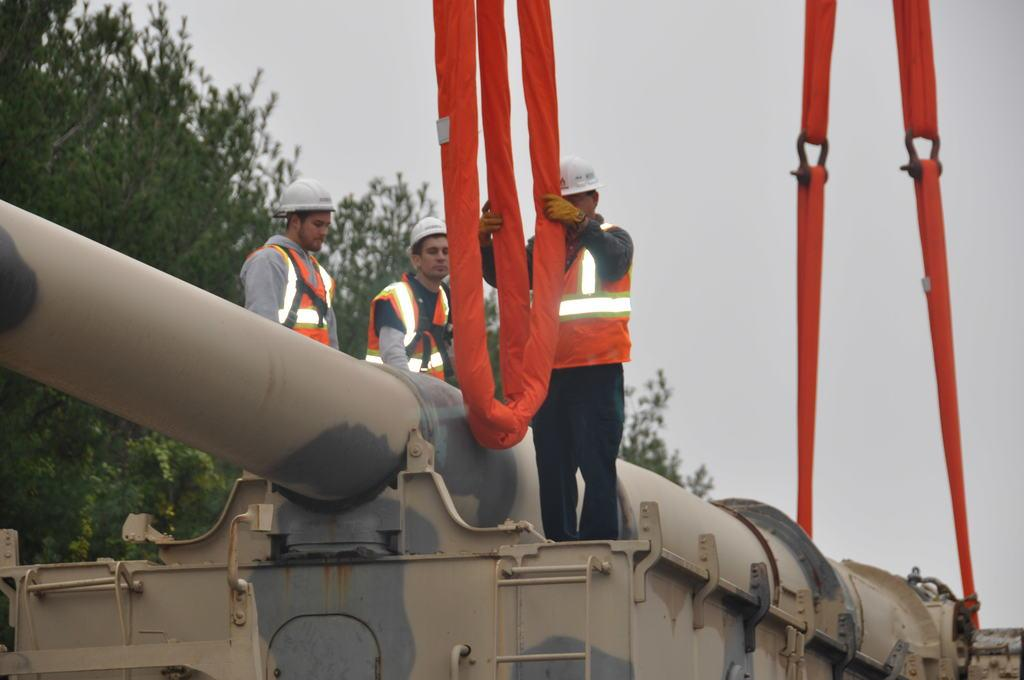How many people are present in the image? There are three people standing in the image. What type of vehicle can be seen in the image? There appears to be a military vehicle in the image. What objects are visible that could be used for tying or securing? There are ropes visible in the image. What type of natural environment is present in the image? There are trees in the image, indicating a forest or wooded area. What is visible in the sky in the image? The sky is visible in the image. What crime is being committed in the image? There is no indication of a crime being committed in the image. What is the position of the sun in the image? The position of the sun is not mentioned in the facts provided, and therefore cannot be determined from the image. 